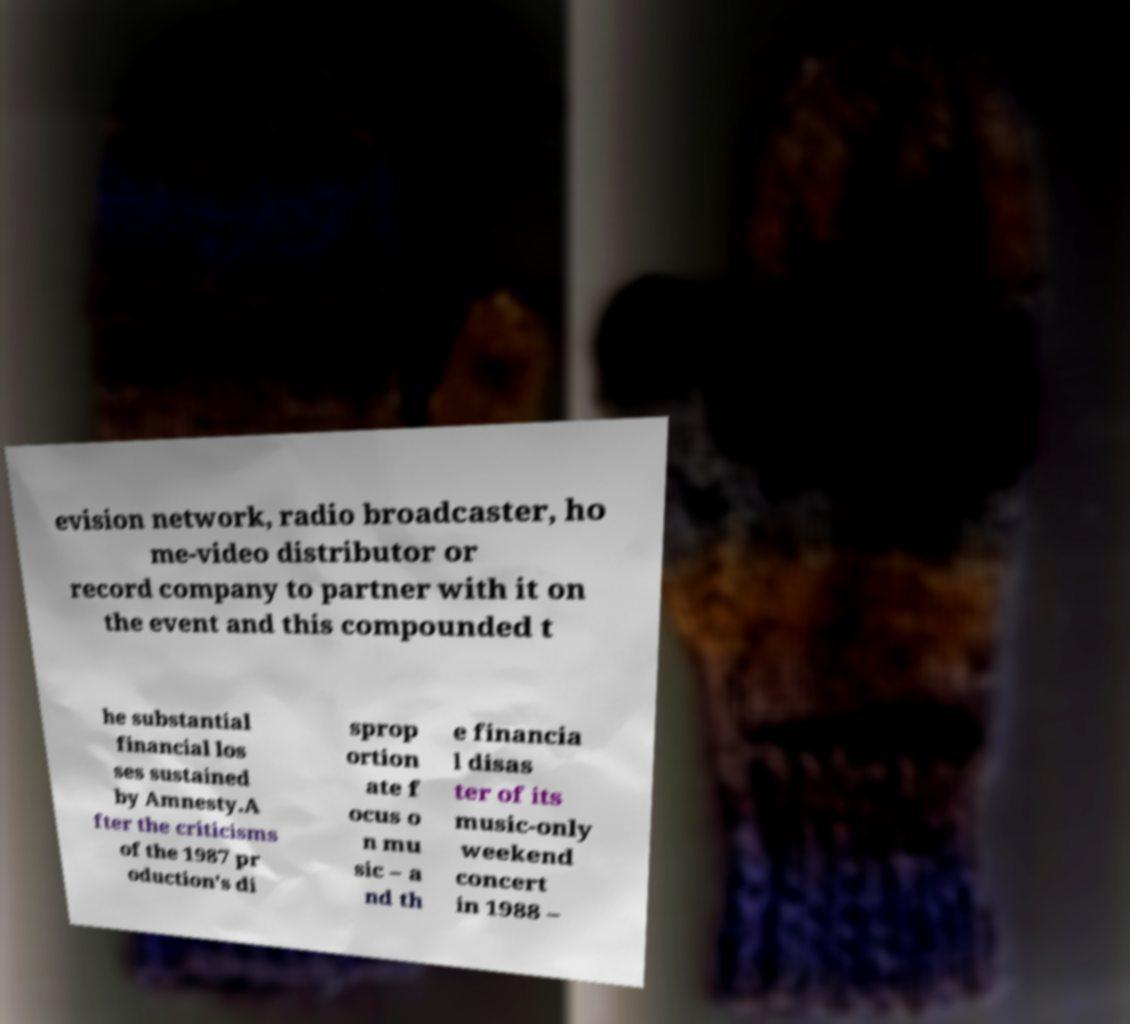For documentation purposes, I need the text within this image transcribed. Could you provide that? evision network, radio broadcaster, ho me-video distributor or record company to partner with it on the event and this compounded t he substantial financial los ses sustained by Amnesty.A fter the criticisms of the 1987 pr oduction's di sprop ortion ate f ocus o n mu sic – a nd th e financia l disas ter of its music-only weekend concert in 1988 – 